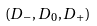Convert formula to latex. <formula><loc_0><loc_0><loc_500><loc_500>( D _ { - } , D _ { 0 } , D _ { + } )</formula> 